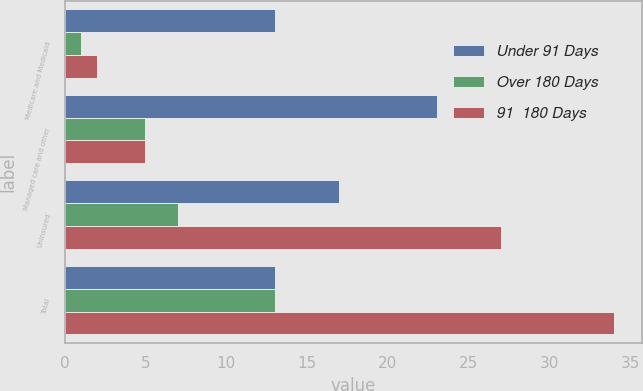Convert chart. <chart><loc_0><loc_0><loc_500><loc_500><stacked_bar_chart><ecel><fcel>Medicare and Medicaid<fcel>Managed care and other<fcel>Uninsured<fcel>Total<nl><fcel>Under 91 Days<fcel>13<fcel>23<fcel>17<fcel>13<nl><fcel>Over 180 Days<fcel>1<fcel>5<fcel>7<fcel>13<nl><fcel>91  180 Days<fcel>2<fcel>5<fcel>27<fcel>34<nl></chart> 